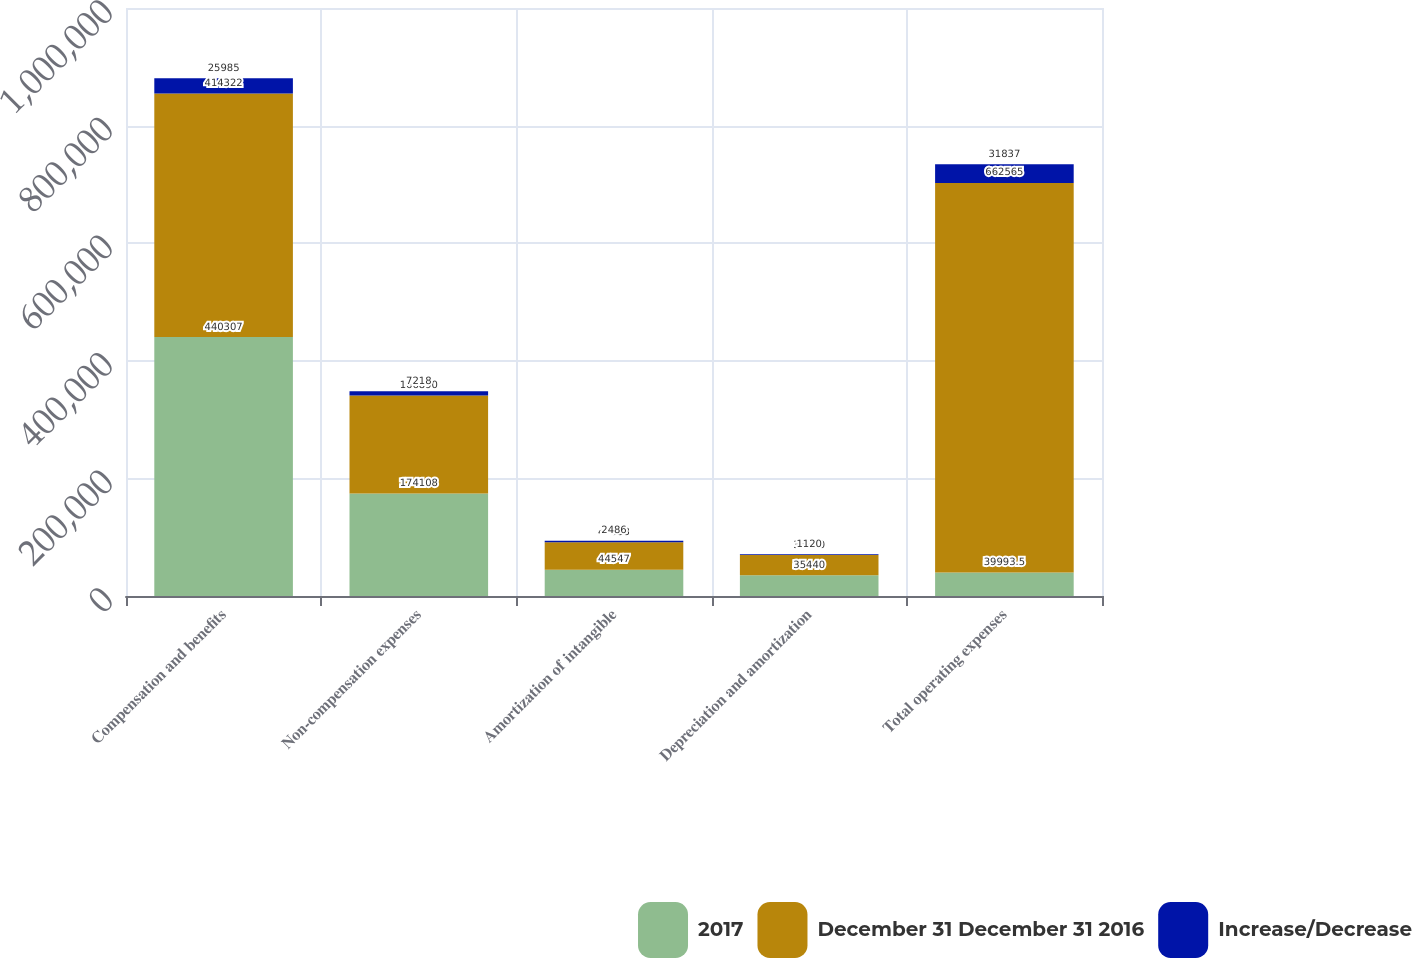Convert chart. <chart><loc_0><loc_0><loc_500><loc_500><stacked_bar_chart><ecel><fcel>Compensation and benefits<fcel>Non-compensation expenses<fcel>Amortization of intangible<fcel>Depreciation and amortization<fcel>Total operating expenses<nl><fcel>2017<fcel>440307<fcel>174108<fcel>44547<fcel>35440<fcel>39993.5<nl><fcel>December 31 December 31 2016<fcel>414322<fcel>166890<fcel>47033<fcel>34320<fcel>662565<nl><fcel>Increase/Decrease<fcel>25985<fcel>7218<fcel>2486<fcel>1120<fcel>31837<nl></chart> 